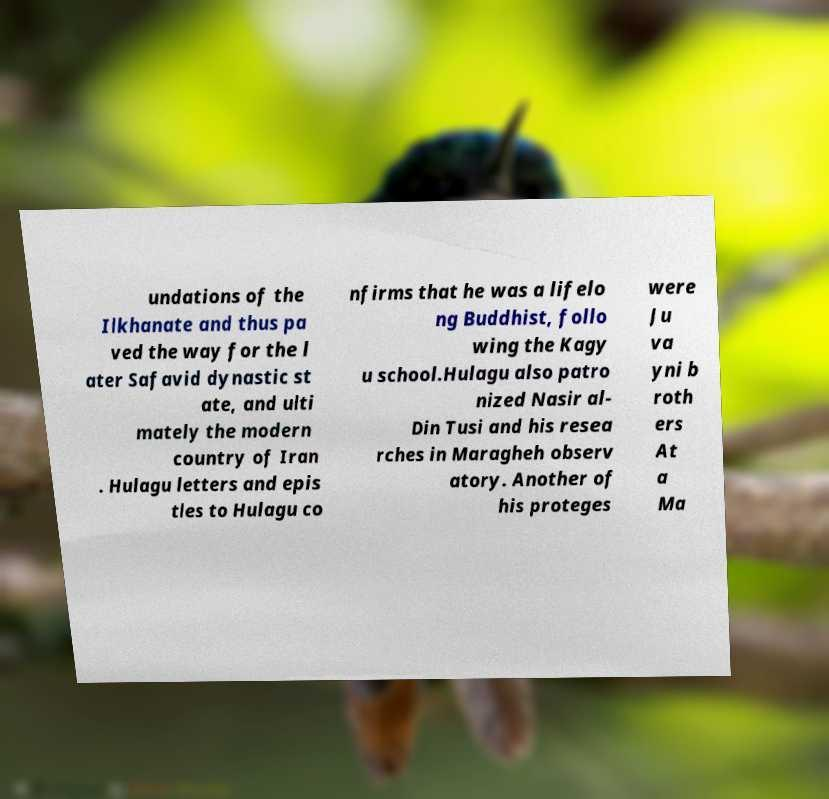What messages or text are displayed in this image? I need them in a readable, typed format. undations of the Ilkhanate and thus pa ved the way for the l ater Safavid dynastic st ate, and ulti mately the modern country of Iran . Hulagu letters and epis tles to Hulagu co nfirms that he was a lifelo ng Buddhist, follo wing the Kagy u school.Hulagu also patro nized Nasir al- Din Tusi and his resea rches in Maragheh observ atory. Another of his proteges were Ju va yni b roth ers At a Ma 